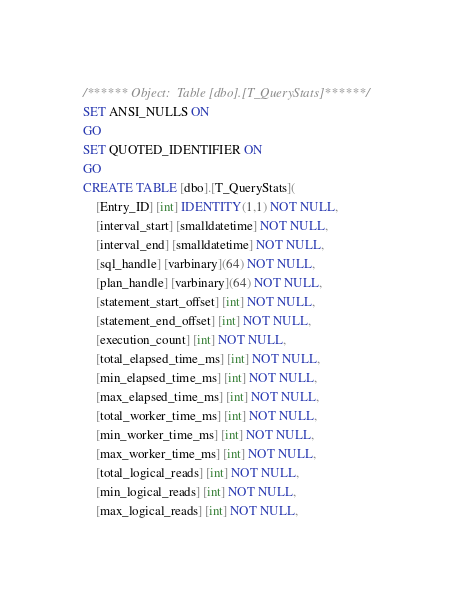<code> <loc_0><loc_0><loc_500><loc_500><_SQL_>/****** Object:  Table [dbo].[T_QueryStats] ******/
SET ANSI_NULLS ON
GO
SET QUOTED_IDENTIFIER ON
GO
CREATE TABLE [dbo].[T_QueryStats](
	[Entry_ID] [int] IDENTITY(1,1) NOT NULL,
	[interval_start] [smalldatetime] NOT NULL,
	[interval_end] [smalldatetime] NOT NULL,
	[sql_handle] [varbinary](64) NOT NULL,
	[plan_handle] [varbinary](64) NOT NULL,
	[statement_start_offset] [int] NOT NULL,
	[statement_end_offset] [int] NOT NULL,
	[execution_count] [int] NOT NULL,
	[total_elapsed_time_ms] [int] NOT NULL,
	[min_elapsed_time_ms] [int] NOT NULL,
	[max_elapsed_time_ms] [int] NOT NULL,
	[total_worker_time_ms] [int] NOT NULL,
	[min_worker_time_ms] [int] NOT NULL,
	[max_worker_time_ms] [int] NOT NULL,
	[total_logical_reads] [int] NOT NULL,
	[min_logical_reads] [int] NOT NULL,
	[max_logical_reads] [int] NOT NULL,</code> 